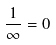<formula> <loc_0><loc_0><loc_500><loc_500>\frac { 1 } { \infty } = 0</formula> 